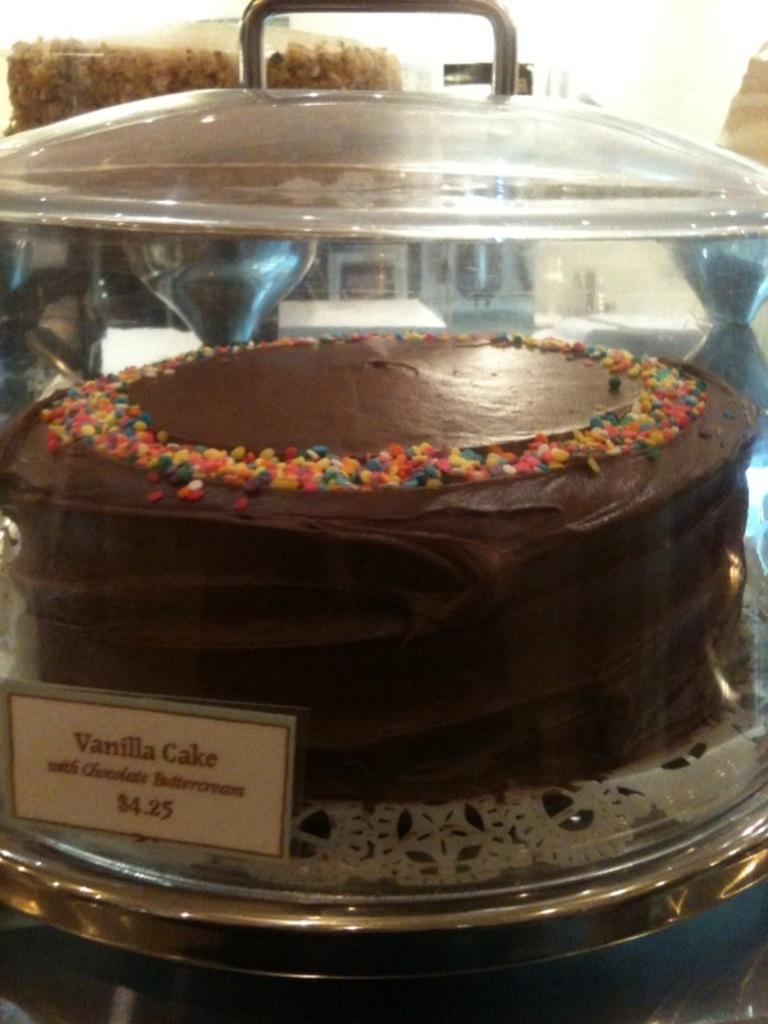What is the main subject of the image? The main subject of the image is a cake. How is the cake displayed in the image? The cake is on a cake stand and covered with a glass lid. Is there any additional information about the cake or its surroundings in the image? Yes, there is a price board in the image. What type of plantation can be seen in the background of the image? There is no plantation present in the image; it features a cake on a cake stand with a glass lid and a price board. 